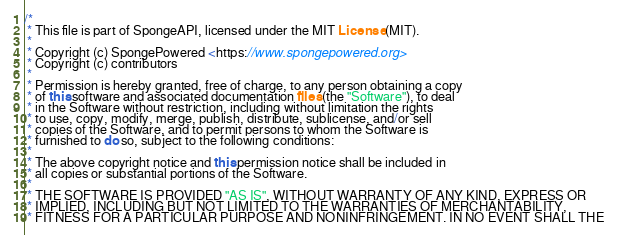Convert code to text. <code><loc_0><loc_0><loc_500><loc_500><_Java_>/*
 * This file is part of SpongeAPI, licensed under the MIT License (MIT).
 *
 * Copyright (c) SpongePowered <https://www.spongepowered.org>
 * Copyright (c) contributors
 *
 * Permission is hereby granted, free of charge, to any person obtaining a copy
 * of this software and associated documentation files (the "Software"), to deal
 * in the Software without restriction, including without limitation the rights
 * to use, copy, modify, merge, publish, distribute, sublicense, and/or sell
 * copies of the Software, and to permit persons to whom the Software is
 * furnished to do so, subject to the following conditions:
 *
 * The above copyright notice and this permission notice shall be included in
 * all copies or substantial portions of the Software.
 *
 * THE SOFTWARE IS PROVIDED "AS IS", WITHOUT WARRANTY OF ANY KIND, EXPRESS OR
 * IMPLIED, INCLUDING BUT NOT LIMITED TO THE WARRANTIES OF MERCHANTABILITY,
 * FITNESS FOR A PARTICULAR PURPOSE AND NONINFRINGEMENT. IN NO EVENT SHALL THE</code> 